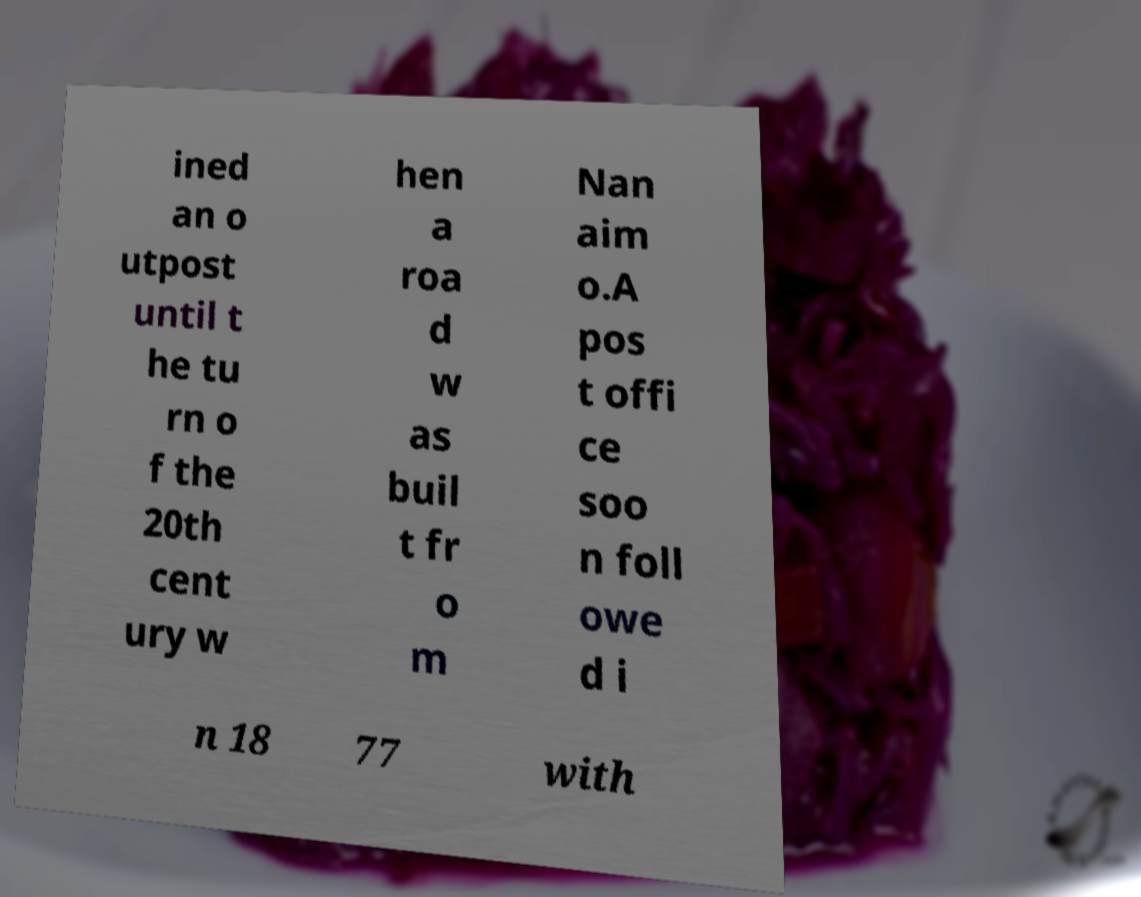Can you accurately transcribe the text from the provided image for me? ined an o utpost until t he tu rn o f the 20th cent ury w hen a roa d w as buil t fr o m Nan aim o.A pos t offi ce soo n foll owe d i n 18 77 with 